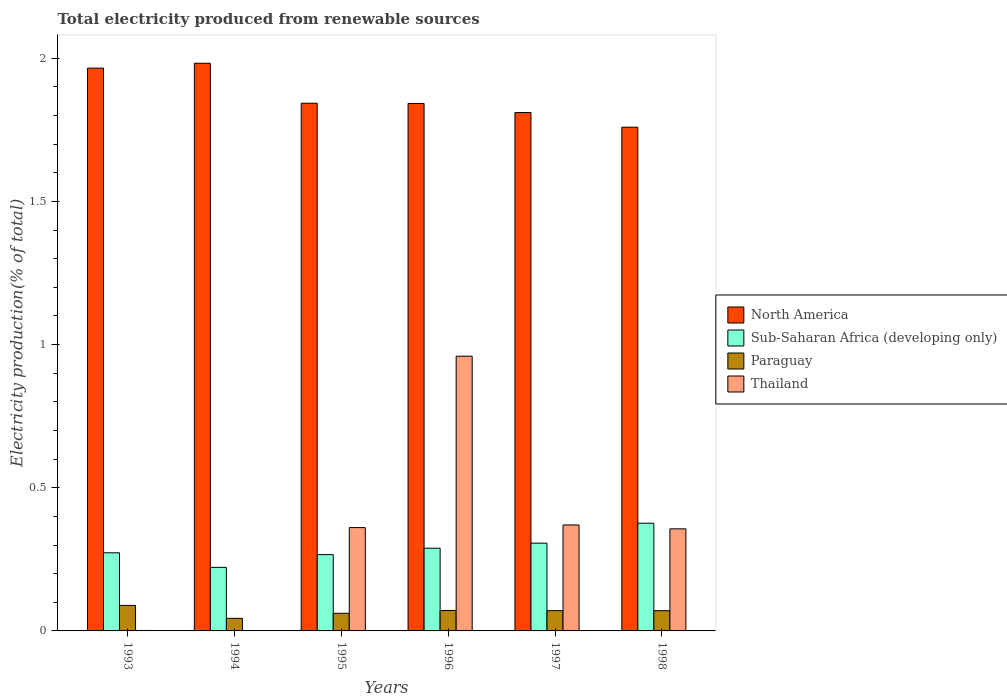How many different coloured bars are there?
Offer a terse response. 4. How many groups of bars are there?
Offer a terse response. 6. Are the number of bars on each tick of the X-axis equal?
Your answer should be very brief. Yes. How many bars are there on the 4th tick from the right?
Ensure brevity in your answer.  4. What is the label of the 1st group of bars from the left?
Ensure brevity in your answer.  1993. What is the total electricity produced in Paraguay in 1995?
Offer a terse response. 0.06. Across all years, what is the maximum total electricity produced in Thailand?
Give a very brief answer. 0.96. Across all years, what is the minimum total electricity produced in North America?
Provide a short and direct response. 1.76. In which year was the total electricity produced in North America maximum?
Offer a very short reply. 1994. In which year was the total electricity produced in Thailand minimum?
Give a very brief answer. 1994. What is the total total electricity produced in Paraguay in the graph?
Ensure brevity in your answer.  0.41. What is the difference between the total electricity produced in North America in 1993 and that in 1996?
Give a very brief answer. 0.12. What is the difference between the total electricity produced in North America in 1993 and the total electricity produced in Thailand in 1995?
Offer a very short reply. 1.6. What is the average total electricity produced in North America per year?
Your answer should be very brief. 1.87. In the year 1997, what is the difference between the total electricity produced in North America and total electricity produced in Paraguay?
Your answer should be compact. 1.74. In how many years, is the total electricity produced in Thailand greater than 0.9 %?
Offer a very short reply. 1. What is the ratio of the total electricity produced in Thailand in 1994 to that in 1997?
Ensure brevity in your answer.  0. Is the total electricity produced in Paraguay in 1994 less than that in 1997?
Make the answer very short. Yes. What is the difference between the highest and the second highest total electricity produced in North America?
Ensure brevity in your answer.  0.02. What is the difference between the highest and the lowest total electricity produced in Paraguay?
Offer a very short reply. 0.05. In how many years, is the total electricity produced in North America greater than the average total electricity produced in North America taken over all years?
Offer a very short reply. 2. Is it the case that in every year, the sum of the total electricity produced in Paraguay and total electricity produced in North America is greater than the sum of total electricity produced in Sub-Saharan Africa (developing only) and total electricity produced in Thailand?
Make the answer very short. Yes. What does the 1st bar from the left in 1993 represents?
Give a very brief answer. North America. What does the 3rd bar from the right in 1993 represents?
Offer a very short reply. Sub-Saharan Africa (developing only). How many bars are there?
Make the answer very short. 24. Where does the legend appear in the graph?
Ensure brevity in your answer.  Center right. How are the legend labels stacked?
Keep it short and to the point. Vertical. What is the title of the graph?
Make the answer very short. Total electricity produced from renewable sources. What is the label or title of the X-axis?
Ensure brevity in your answer.  Years. What is the label or title of the Y-axis?
Keep it short and to the point. Electricity production(% of total). What is the Electricity production(% of total) of North America in 1993?
Give a very brief answer. 1.97. What is the Electricity production(% of total) in Sub-Saharan Africa (developing only) in 1993?
Your response must be concise. 0.27. What is the Electricity production(% of total) of Paraguay in 1993?
Provide a short and direct response. 0.09. What is the Electricity production(% of total) in Thailand in 1993?
Your response must be concise. 0. What is the Electricity production(% of total) in North America in 1994?
Your answer should be compact. 1.98. What is the Electricity production(% of total) in Sub-Saharan Africa (developing only) in 1994?
Ensure brevity in your answer.  0.22. What is the Electricity production(% of total) of Paraguay in 1994?
Your answer should be very brief. 0.04. What is the Electricity production(% of total) of Thailand in 1994?
Give a very brief answer. 0. What is the Electricity production(% of total) in North America in 1995?
Ensure brevity in your answer.  1.84. What is the Electricity production(% of total) of Sub-Saharan Africa (developing only) in 1995?
Your response must be concise. 0.27. What is the Electricity production(% of total) in Paraguay in 1995?
Give a very brief answer. 0.06. What is the Electricity production(% of total) in Thailand in 1995?
Your answer should be compact. 0.36. What is the Electricity production(% of total) in North America in 1996?
Provide a short and direct response. 1.84. What is the Electricity production(% of total) of Sub-Saharan Africa (developing only) in 1996?
Keep it short and to the point. 0.29. What is the Electricity production(% of total) of Paraguay in 1996?
Your response must be concise. 0.07. What is the Electricity production(% of total) of Thailand in 1996?
Offer a very short reply. 0.96. What is the Electricity production(% of total) in North America in 1997?
Your answer should be compact. 1.81. What is the Electricity production(% of total) in Sub-Saharan Africa (developing only) in 1997?
Offer a terse response. 0.31. What is the Electricity production(% of total) in Paraguay in 1997?
Give a very brief answer. 0.07. What is the Electricity production(% of total) in Thailand in 1997?
Provide a short and direct response. 0.37. What is the Electricity production(% of total) in North America in 1998?
Your response must be concise. 1.76. What is the Electricity production(% of total) in Sub-Saharan Africa (developing only) in 1998?
Provide a short and direct response. 0.38. What is the Electricity production(% of total) in Paraguay in 1998?
Offer a terse response. 0.07. What is the Electricity production(% of total) of Thailand in 1998?
Offer a terse response. 0.36. Across all years, what is the maximum Electricity production(% of total) of North America?
Your answer should be very brief. 1.98. Across all years, what is the maximum Electricity production(% of total) in Sub-Saharan Africa (developing only)?
Give a very brief answer. 0.38. Across all years, what is the maximum Electricity production(% of total) in Paraguay?
Give a very brief answer. 0.09. Across all years, what is the maximum Electricity production(% of total) of Thailand?
Ensure brevity in your answer.  0.96. Across all years, what is the minimum Electricity production(% of total) of North America?
Offer a terse response. 1.76. Across all years, what is the minimum Electricity production(% of total) of Sub-Saharan Africa (developing only)?
Your answer should be very brief. 0.22. Across all years, what is the minimum Electricity production(% of total) in Paraguay?
Make the answer very short. 0.04. Across all years, what is the minimum Electricity production(% of total) of Thailand?
Your answer should be compact. 0. What is the total Electricity production(% of total) of North America in the graph?
Keep it short and to the point. 11.2. What is the total Electricity production(% of total) of Sub-Saharan Africa (developing only) in the graph?
Provide a succinct answer. 1.73. What is the total Electricity production(% of total) in Paraguay in the graph?
Ensure brevity in your answer.  0.41. What is the total Electricity production(% of total) of Thailand in the graph?
Ensure brevity in your answer.  2.05. What is the difference between the Electricity production(% of total) of North America in 1993 and that in 1994?
Your answer should be very brief. -0.02. What is the difference between the Electricity production(% of total) of Sub-Saharan Africa (developing only) in 1993 and that in 1994?
Give a very brief answer. 0.05. What is the difference between the Electricity production(% of total) in Paraguay in 1993 and that in 1994?
Provide a short and direct response. 0.05. What is the difference between the Electricity production(% of total) in North America in 1993 and that in 1995?
Give a very brief answer. 0.12. What is the difference between the Electricity production(% of total) in Sub-Saharan Africa (developing only) in 1993 and that in 1995?
Your answer should be compact. 0.01. What is the difference between the Electricity production(% of total) of Paraguay in 1993 and that in 1995?
Your response must be concise. 0.03. What is the difference between the Electricity production(% of total) in Thailand in 1993 and that in 1995?
Your answer should be compact. -0.36. What is the difference between the Electricity production(% of total) in North America in 1993 and that in 1996?
Offer a very short reply. 0.12. What is the difference between the Electricity production(% of total) in Sub-Saharan Africa (developing only) in 1993 and that in 1996?
Offer a very short reply. -0.02. What is the difference between the Electricity production(% of total) of Paraguay in 1993 and that in 1996?
Your answer should be very brief. 0.02. What is the difference between the Electricity production(% of total) in Thailand in 1993 and that in 1996?
Provide a succinct answer. -0.96. What is the difference between the Electricity production(% of total) of North America in 1993 and that in 1997?
Provide a succinct answer. 0.16. What is the difference between the Electricity production(% of total) in Sub-Saharan Africa (developing only) in 1993 and that in 1997?
Offer a very short reply. -0.03. What is the difference between the Electricity production(% of total) in Paraguay in 1993 and that in 1997?
Your answer should be very brief. 0.02. What is the difference between the Electricity production(% of total) of Thailand in 1993 and that in 1997?
Make the answer very short. -0.37. What is the difference between the Electricity production(% of total) in North America in 1993 and that in 1998?
Ensure brevity in your answer.  0.21. What is the difference between the Electricity production(% of total) in Sub-Saharan Africa (developing only) in 1993 and that in 1998?
Provide a succinct answer. -0.1. What is the difference between the Electricity production(% of total) in Paraguay in 1993 and that in 1998?
Keep it short and to the point. 0.02. What is the difference between the Electricity production(% of total) in Thailand in 1993 and that in 1998?
Make the answer very short. -0.35. What is the difference between the Electricity production(% of total) of North America in 1994 and that in 1995?
Offer a terse response. 0.14. What is the difference between the Electricity production(% of total) in Sub-Saharan Africa (developing only) in 1994 and that in 1995?
Your answer should be very brief. -0.04. What is the difference between the Electricity production(% of total) in Paraguay in 1994 and that in 1995?
Your response must be concise. -0.02. What is the difference between the Electricity production(% of total) in Thailand in 1994 and that in 1995?
Your answer should be compact. -0.36. What is the difference between the Electricity production(% of total) of North America in 1994 and that in 1996?
Provide a succinct answer. 0.14. What is the difference between the Electricity production(% of total) of Sub-Saharan Africa (developing only) in 1994 and that in 1996?
Provide a short and direct response. -0.07. What is the difference between the Electricity production(% of total) of Paraguay in 1994 and that in 1996?
Ensure brevity in your answer.  -0.03. What is the difference between the Electricity production(% of total) of Thailand in 1994 and that in 1996?
Offer a very short reply. -0.96. What is the difference between the Electricity production(% of total) of North America in 1994 and that in 1997?
Provide a short and direct response. 0.17. What is the difference between the Electricity production(% of total) in Sub-Saharan Africa (developing only) in 1994 and that in 1997?
Keep it short and to the point. -0.08. What is the difference between the Electricity production(% of total) of Paraguay in 1994 and that in 1997?
Offer a terse response. -0.03. What is the difference between the Electricity production(% of total) of Thailand in 1994 and that in 1997?
Your response must be concise. -0.37. What is the difference between the Electricity production(% of total) of North America in 1994 and that in 1998?
Give a very brief answer. 0.22. What is the difference between the Electricity production(% of total) of Sub-Saharan Africa (developing only) in 1994 and that in 1998?
Your answer should be compact. -0.15. What is the difference between the Electricity production(% of total) in Paraguay in 1994 and that in 1998?
Offer a terse response. -0.03. What is the difference between the Electricity production(% of total) of Thailand in 1994 and that in 1998?
Give a very brief answer. -0.36. What is the difference between the Electricity production(% of total) of North America in 1995 and that in 1996?
Give a very brief answer. 0. What is the difference between the Electricity production(% of total) in Sub-Saharan Africa (developing only) in 1995 and that in 1996?
Provide a succinct answer. -0.02. What is the difference between the Electricity production(% of total) in Paraguay in 1995 and that in 1996?
Offer a terse response. -0.01. What is the difference between the Electricity production(% of total) in Thailand in 1995 and that in 1996?
Ensure brevity in your answer.  -0.6. What is the difference between the Electricity production(% of total) in North America in 1995 and that in 1997?
Make the answer very short. 0.03. What is the difference between the Electricity production(% of total) of Sub-Saharan Africa (developing only) in 1995 and that in 1997?
Offer a terse response. -0.04. What is the difference between the Electricity production(% of total) of Paraguay in 1995 and that in 1997?
Keep it short and to the point. -0.01. What is the difference between the Electricity production(% of total) in Thailand in 1995 and that in 1997?
Your response must be concise. -0.01. What is the difference between the Electricity production(% of total) of North America in 1995 and that in 1998?
Give a very brief answer. 0.08. What is the difference between the Electricity production(% of total) in Sub-Saharan Africa (developing only) in 1995 and that in 1998?
Make the answer very short. -0.11. What is the difference between the Electricity production(% of total) in Paraguay in 1995 and that in 1998?
Your response must be concise. -0.01. What is the difference between the Electricity production(% of total) in Thailand in 1995 and that in 1998?
Provide a short and direct response. 0. What is the difference between the Electricity production(% of total) of North America in 1996 and that in 1997?
Keep it short and to the point. 0.03. What is the difference between the Electricity production(% of total) of Sub-Saharan Africa (developing only) in 1996 and that in 1997?
Provide a short and direct response. -0.02. What is the difference between the Electricity production(% of total) in Paraguay in 1996 and that in 1997?
Make the answer very short. 0. What is the difference between the Electricity production(% of total) of Thailand in 1996 and that in 1997?
Give a very brief answer. 0.59. What is the difference between the Electricity production(% of total) of North America in 1996 and that in 1998?
Provide a short and direct response. 0.08. What is the difference between the Electricity production(% of total) in Sub-Saharan Africa (developing only) in 1996 and that in 1998?
Give a very brief answer. -0.09. What is the difference between the Electricity production(% of total) of Paraguay in 1996 and that in 1998?
Provide a succinct answer. 0. What is the difference between the Electricity production(% of total) of Thailand in 1996 and that in 1998?
Your response must be concise. 0.6. What is the difference between the Electricity production(% of total) in North America in 1997 and that in 1998?
Provide a short and direct response. 0.05. What is the difference between the Electricity production(% of total) in Sub-Saharan Africa (developing only) in 1997 and that in 1998?
Offer a terse response. -0.07. What is the difference between the Electricity production(% of total) of Paraguay in 1997 and that in 1998?
Give a very brief answer. 0. What is the difference between the Electricity production(% of total) in Thailand in 1997 and that in 1998?
Make the answer very short. 0.01. What is the difference between the Electricity production(% of total) of North America in 1993 and the Electricity production(% of total) of Sub-Saharan Africa (developing only) in 1994?
Your answer should be compact. 1.74. What is the difference between the Electricity production(% of total) in North America in 1993 and the Electricity production(% of total) in Paraguay in 1994?
Your response must be concise. 1.92. What is the difference between the Electricity production(% of total) in North America in 1993 and the Electricity production(% of total) in Thailand in 1994?
Keep it short and to the point. 1.96. What is the difference between the Electricity production(% of total) in Sub-Saharan Africa (developing only) in 1993 and the Electricity production(% of total) in Paraguay in 1994?
Offer a very short reply. 0.23. What is the difference between the Electricity production(% of total) in Sub-Saharan Africa (developing only) in 1993 and the Electricity production(% of total) in Thailand in 1994?
Your response must be concise. 0.27. What is the difference between the Electricity production(% of total) in Paraguay in 1993 and the Electricity production(% of total) in Thailand in 1994?
Provide a succinct answer. 0.09. What is the difference between the Electricity production(% of total) in North America in 1993 and the Electricity production(% of total) in Sub-Saharan Africa (developing only) in 1995?
Keep it short and to the point. 1.7. What is the difference between the Electricity production(% of total) in North America in 1993 and the Electricity production(% of total) in Paraguay in 1995?
Provide a succinct answer. 1.9. What is the difference between the Electricity production(% of total) in North America in 1993 and the Electricity production(% of total) in Thailand in 1995?
Provide a short and direct response. 1.6. What is the difference between the Electricity production(% of total) of Sub-Saharan Africa (developing only) in 1993 and the Electricity production(% of total) of Paraguay in 1995?
Keep it short and to the point. 0.21. What is the difference between the Electricity production(% of total) in Sub-Saharan Africa (developing only) in 1993 and the Electricity production(% of total) in Thailand in 1995?
Make the answer very short. -0.09. What is the difference between the Electricity production(% of total) in Paraguay in 1993 and the Electricity production(% of total) in Thailand in 1995?
Ensure brevity in your answer.  -0.27. What is the difference between the Electricity production(% of total) in North America in 1993 and the Electricity production(% of total) in Sub-Saharan Africa (developing only) in 1996?
Ensure brevity in your answer.  1.68. What is the difference between the Electricity production(% of total) of North America in 1993 and the Electricity production(% of total) of Paraguay in 1996?
Ensure brevity in your answer.  1.89. What is the difference between the Electricity production(% of total) in Sub-Saharan Africa (developing only) in 1993 and the Electricity production(% of total) in Paraguay in 1996?
Your answer should be compact. 0.2. What is the difference between the Electricity production(% of total) of Sub-Saharan Africa (developing only) in 1993 and the Electricity production(% of total) of Thailand in 1996?
Provide a succinct answer. -0.69. What is the difference between the Electricity production(% of total) of Paraguay in 1993 and the Electricity production(% of total) of Thailand in 1996?
Offer a very short reply. -0.87. What is the difference between the Electricity production(% of total) in North America in 1993 and the Electricity production(% of total) in Sub-Saharan Africa (developing only) in 1997?
Make the answer very short. 1.66. What is the difference between the Electricity production(% of total) of North America in 1993 and the Electricity production(% of total) of Paraguay in 1997?
Provide a succinct answer. 1.89. What is the difference between the Electricity production(% of total) in North America in 1993 and the Electricity production(% of total) in Thailand in 1997?
Offer a terse response. 1.6. What is the difference between the Electricity production(% of total) of Sub-Saharan Africa (developing only) in 1993 and the Electricity production(% of total) of Paraguay in 1997?
Provide a succinct answer. 0.2. What is the difference between the Electricity production(% of total) in Sub-Saharan Africa (developing only) in 1993 and the Electricity production(% of total) in Thailand in 1997?
Provide a short and direct response. -0.1. What is the difference between the Electricity production(% of total) of Paraguay in 1993 and the Electricity production(% of total) of Thailand in 1997?
Your answer should be compact. -0.28. What is the difference between the Electricity production(% of total) in North America in 1993 and the Electricity production(% of total) in Sub-Saharan Africa (developing only) in 1998?
Make the answer very short. 1.59. What is the difference between the Electricity production(% of total) in North America in 1993 and the Electricity production(% of total) in Paraguay in 1998?
Your response must be concise. 1.89. What is the difference between the Electricity production(% of total) in North America in 1993 and the Electricity production(% of total) in Thailand in 1998?
Keep it short and to the point. 1.61. What is the difference between the Electricity production(% of total) of Sub-Saharan Africa (developing only) in 1993 and the Electricity production(% of total) of Paraguay in 1998?
Your answer should be compact. 0.2. What is the difference between the Electricity production(% of total) of Sub-Saharan Africa (developing only) in 1993 and the Electricity production(% of total) of Thailand in 1998?
Give a very brief answer. -0.08. What is the difference between the Electricity production(% of total) in Paraguay in 1993 and the Electricity production(% of total) in Thailand in 1998?
Make the answer very short. -0.27. What is the difference between the Electricity production(% of total) in North America in 1994 and the Electricity production(% of total) in Sub-Saharan Africa (developing only) in 1995?
Give a very brief answer. 1.72. What is the difference between the Electricity production(% of total) in North America in 1994 and the Electricity production(% of total) in Paraguay in 1995?
Ensure brevity in your answer.  1.92. What is the difference between the Electricity production(% of total) of North America in 1994 and the Electricity production(% of total) of Thailand in 1995?
Your response must be concise. 1.62. What is the difference between the Electricity production(% of total) of Sub-Saharan Africa (developing only) in 1994 and the Electricity production(% of total) of Paraguay in 1995?
Provide a short and direct response. 0.16. What is the difference between the Electricity production(% of total) in Sub-Saharan Africa (developing only) in 1994 and the Electricity production(% of total) in Thailand in 1995?
Make the answer very short. -0.14. What is the difference between the Electricity production(% of total) in Paraguay in 1994 and the Electricity production(% of total) in Thailand in 1995?
Ensure brevity in your answer.  -0.32. What is the difference between the Electricity production(% of total) in North America in 1994 and the Electricity production(% of total) in Sub-Saharan Africa (developing only) in 1996?
Keep it short and to the point. 1.69. What is the difference between the Electricity production(% of total) in North America in 1994 and the Electricity production(% of total) in Paraguay in 1996?
Provide a short and direct response. 1.91. What is the difference between the Electricity production(% of total) of North America in 1994 and the Electricity production(% of total) of Thailand in 1996?
Provide a short and direct response. 1.02. What is the difference between the Electricity production(% of total) in Sub-Saharan Africa (developing only) in 1994 and the Electricity production(% of total) in Paraguay in 1996?
Your answer should be very brief. 0.15. What is the difference between the Electricity production(% of total) in Sub-Saharan Africa (developing only) in 1994 and the Electricity production(% of total) in Thailand in 1996?
Your response must be concise. -0.74. What is the difference between the Electricity production(% of total) of Paraguay in 1994 and the Electricity production(% of total) of Thailand in 1996?
Your response must be concise. -0.92. What is the difference between the Electricity production(% of total) of North America in 1994 and the Electricity production(% of total) of Sub-Saharan Africa (developing only) in 1997?
Your response must be concise. 1.68. What is the difference between the Electricity production(% of total) in North America in 1994 and the Electricity production(% of total) in Paraguay in 1997?
Ensure brevity in your answer.  1.91. What is the difference between the Electricity production(% of total) in North America in 1994 and the Electricity production(% of total) in Thailand in 1997?
Ensure brevity in your answer.  1.61. What is the difference between the Electricity production(% of total) of Sub-Saharan Africa (developing only) in 1994 and the Electricity production(% of total) of Paraguay in 1997?
Make the answer very short. 0.15. What is the difference between the Electricity production(% of total) in Sub-Saharan Africa (developing only) in 1994 and the Electricity production(% of total) in Thailand in 1997?
Give a very brief answer. -0.15. What is the difference between the Electricity production(% of total) of Paraguay in 1994 and the Electricity production(% of total) of Thailand in 1997?
Your answer should be compact. -0.33. What is the difference between the Electricity production(% of total) in North America in 1994 and the Electricity production(% of total) in Sub-Saharan Africa (developing only) in 1998?
Offer a very short reply. 1.61. What is the difference between the Electricity production(% of total) of North America in 1994 and the Electricity production(% of total) of Paraguay in 1998?
Offer a terse response. 1.91. What is the difference between the Electricity production(% of total) in North America in 1994 and the Electricity production(% of total) in Thailand in 1998?
Your answer should be very brief. 1.63. What is the difference between the Electricity production(% of total) in Sub-Saharan Africa (developing only) in 1994 and the Electricity production(% of total) in Paraguay in 1998?
Offer a terse response. 0.15. What is the difference between the Electricity production(% of total) of Sub-Saharan Africa (developing only) in 1994 and the Electricity production(% of total) of Thailand in 1998?
Offer a terse response. -0.13. What is the difference between the Electricity production(% of total) of Paraguay in 1994 and the Electricity production(% of total) of Thailand in 1998?
Offer a terse response. -0.31. What is the difference between the Electricity production(% of total) of North America in 1995 and the Electricity production(% of total) of Sub-Saharan Africa (developing only) in 1996?
Offer a terse response. 1.55. What is the difference between the Electricity production(% of total) in North America in 1995 and the Electricity production(% of total) in Paraguay in 1996?
Provide a short and direct response. 1.77. What is the difference between the Electricity production(% of total) of North America in 1995 and the Electricity production(% of total) of Thailand in 1996?
Your answer should be very brief. 0.88. What is the difference between the Electricity production(% of total) of Sub-Saharan Africa (developing only) in 1995 and the Electricity production(% of total) of Paraguay in 1996?
Provide a short and direct response. 0.2. What is the difference between the Electricity production(% of total) of Sub-Saharan Africa (developing only) in 1995 and the Electricity production(% of total) of Thailand in 1996?
Make the answer very short. -0.69. What is the difference between the Electricity production(% of total) in Paraguay in 1995 and the Electricity production(% of total) in Thailand in 1996?
Offer a very short reply. -0.9. What is the difference between the Electricity production(% of total) in North America in 1995 and the Electricity production(% of total) in Sub-Saharan Africa (developing only) in 1997?
Provide a short and direct response. 1.54. What is the difference between the Electricity production(% of total) in North America in 1995 and the Electricity production(% of total) in Paraguay in 1997?
Your answer should be very brief. 1.77. What is the difference between the Electricity production(% of total) in North America in 1995 and the Electricity production(% of total) in Thailand in 1997?
Your answer should be very brief. 1.47. What is the difference between the Electricity production(% of total) in Sub-Saharan Africa (developing only) in 1995 and the Electricity production(% of total) in Paraguay in 1997?
Offer a terse response. 0.2. What is the difference between the Electricity production(% of total) of Sub-Saharan Africa (developing only) in 1995 and the Electricity production(% of total) of Thailand in 1997?
Provide a short and direct response. -0.1. What is the difference between the Electricity production(% of total) of Paraguay in 1995 and the Electricity production(% of total) of Thailand in 1997?
Ensure brevity in your answer.  -0.31. What is the difference between the Electricity production(% of total) in North America in 1995 and the Electricity production(% of total) in Sub-Saharan Africa (developing only) in 1998?
Give a very brief answer. 1.47. What is the difference between the Electricity production(% of total) of North America in 1995 and the Electricity production(% of total) of Paraguay in 1998?
Offer a very short reply. 1.77. What is the difference between the Electricity production(% of total) of North America in 1995 and the Electricity production(% of total) of Thailand in 1998?
Ensure brevity in your answer.  1.49. What is the difference between the Electricity production(% of total) in Sub-Saharan Africa (developing only) in 1995 and the Electricity production(% of total) in Paraguay in 1998?
Provide a succinct answer. 0.2. What is the difference between the Electricity production(% of total) in Sub-Saharan Africa (developing only) in 1995 and the Electricity production(% of total) in Thailand in 1998?
Provide a succinct answer. -0.09. What is the difference between the Electricity production(% of total) in Paraguay in 1995 and the Electricity production(% of total) in Thailand in 1998?
Keep it short and to the point. -0.29. What is the difference between the Electricity production(% of total) of North America in 1996 and the Electricity production(% of total) of Sub-Saharan Africa (developing only) in 1997?
Your answer should be very brief. 1.54. What is the difference between the Electricity production(% of total) in North America in 1996 and the Electricity production(% of total) in Paraguay in 1997?
Ensure brevity in your answer.  1.77. What is the difference between the Electricity production(% of total) in North America in 1996 and the Electricity production(% of total) in Thailand in 1997?
Your response must be concise. 1.47. What is the difference between the Electricity production(% of total) of Sub-Saharan Africa (developing only) in 1996 and the Electricity production(% of total) of Paraguay in 1997?
Offer a terse response. 0.22. What is the difference between the Electricity production(% of total) of Sub-Saharan Africa (developing only) in 1996 and the Electricity production(% of total) of Thailand in 1997?
Give a very brief answer. -0.08. What is the difference between the Electricity production(% of total) in Paraguay in 1996 and the Electricity production(% of total) in Thailand in 1997?
Make the answer very short. -0.3. What is the difference between the Electricity production(% of total) of North America in 1996 and the Electricity production(% of total) of Sub-Saharan Africa (developing only) in 1998?
Your answer should be very brief. 1.47. What is the difference between the Electricity production(% of total) of North America in 1996 and the Electricity production(% of total) of Paraguay in 1998?
Your response must be concise. 1.77. What is the difference between the Electricity production(% of total) of North America in 1996 and the Electricity production(% of total) of Thailand in 1998?
Your answer should be very brief. 1.49. What is the difference between the Electricity production(% of total) in Sub-Saharan Africa (developing only) in 1996 and the Electricity production(% of total) in Paraguay in 1998?
Provide a succinct answer. 0.22. What is the difference between the Electricity production(% of total) in Sub-Saharan Africa (developing only) in 1996 and the Electricity production(% of total) in Thailand in 1998?
Make the answer very short. -0.07. What is the difference between the Electricity production(% of total) of Paraguay in 1996 and the Electricity production(% of total) of Thailand in 1998?
Your answer should be compact. -0.29. What is the difference between the Electricity production(% of total) in North America in 1997 and the Electricity production(% of total) in Sub-Saharan Africa (developing only) in 1998?
Keep it short and to the point. 1.43. What is the difference between the Electricity production(% of total) of North America in 1997 and the Electricity production(% of total) of Paraguay in 1998?
Provide a succinct answer. 1.74. What is the difference between the Electricity production(% of total) of North America in 1997 and the Electricity production(% of total) of Thailand in 1998?
Offer a very short reply. 1.45. What is the difference between the Electricity production(% of total) in Sub-Saharan Africa (developing only) in 1997 and the Electricity production(% of total) in Paraguay in 1998?
Give a very brief answer. 0.24. What is the difference between the Electricity production(% of total) in Sub-Saharan Africa (developing only) in 1997 and the Electricity production(% of total) in Thailand in 1998?
Make the answer very short. -0.05. What is the difference between the Electricity production(% of total) of Paraguay in 1997 and the Electricity production(% of total) of Thailand in 1998?
Offer a very short reply. -0.29. What is the average Electricity production(% of total) of North America per year?
Provide a succinct answer. 1.87. What is the average Electricity production(% of total) of Sub-Saharan Africa (developing only) per year?
Your response must be concise. 0.29. What is the average Electricity production(% of total) in Paraguay per year?
Offer a terse response. 0.07. What is the average Electricity production(% of total) in Thailand per year?
Your answer should be compact. 0.34. In the year 1993, what is the difference between the Electricity production(% of total) in North America and Electricity production(% of total) in Sub-Saharan Africa (developing only)?
Give a very brief answer. 1.69. In the year 1993, what is the difference between the Electricity production(% of total) of North America and Electricity production(% of total) of Paraguay?
Offer a very short reply. 1.88. In the year 1993, what is the difference between the Electricity production(% of total) in North America and Electricity production(% of total) in Thailand?
Offer a terse response. 1.96. In the year 1993, what is the difference between the Electricity production(% of total) in Sub-Saharan Africa (developing only) and Electricity production(% of total) in Paraguay?
Your response must be concise. 0.18. In the year 1993, what is the difference between the Electricity production(% of total) in Sub-Saharan Africa (developing only) and Electricity production(% of total) in Thailand?
Give a very brief answer. 0.27. In the year 1993, what is the difference between the Electricity production(% of total) of Paraguay and Electricity production(% of total) of Thailand?
Your answer should be very brief. 0.09. In the year 1994, what is the difference between the Electricity production(% of total) of North America and Electricity production(% of total) of Sub-Saharan Africa (developing only)?
Provide a succinct answer. 1.76. In the year 1994, what is the difference between the Electricity production(% of total) of North America and Electricity production(% of total) of Paraguay?
Ensure brevity in your answer.  1.94. In the year 1994, what is the difference between the Electricity production(% of total) of North America and Electricity production(% of total) of Thailand?
Provide a succinct answer. 1.98. In the year 1994, what is the difference between the Electricity production(% of total) of Sub-Saharan Africa (developing only) and Electricity production(% of total) of Paraguay?
Offer a terse response. 0.18. In the year 1994, what is the difference between the Electricity production(% of total) in Sub-Saharan Africa (developing only) and Electricity production(% of total) in Thailand?
Provide a succinct answer. 0.22. In the year 1994, what is the difference between the Electricity production(% of total) in Paraguay and Electricity production(% of total) in Thailand?
Ensure brevity in your answer.  0.04. In the year 1995, what is the difference between the Electricity production(% of total) in North America and Electricity production(% of total) in Sub-Saharan Africa (developing only)?
Offer a very short reply. 1.58. In the year 1995, what is the difference between the Electricity production(% of total) of North America and Electricity production(% of total) of Paraguay?
Your answer should be very brief. 1.78. In the year 1995, what is the difference between the Electricity production(% of total) in North America and Electricity production(% of total) in Thailand?
Offer a terse response. 1.48. In the year 1995, what is the difference between the Electricity production(% of total) of Sub-Saharan Africa (developing only) and Electricity production(% of total) of Paraguay?
Give a very brief answer. 0.2. In the year 1995, what is the difference between the Electricity production(% of total) of Sub-Saharan Africa (developing only) and Electricity production(% of total) of Thailand?
Provide a short and direct response. -0.09. In the year 1995, what is the difference between the Electricity production(% of total) of Paraguay and Electricity production(% of total) of Thailand?
Provide a succinct answer. -0.3. In the year 1996, what is the difference between the Electricity production(% of total) of North America and Electricity production(% of total) of Sub-Saharan Africa (developing only)?
Offer a very short reply. 1.55. In the year 1996, what is the difference between the Electricity production(% of total) in North America and Electricity production(% of total) in Paraguay?
Keep it short and to the point. 1.77. In the year 1996, what is the difference between the Electricity production(% of total) in North America and Electricity production(% of total) in Thailand?
Keep it short and to the point. 0.88. In the year 1996, what is the difference between the Electricity production(% of total) in Sub-Saharan Africa (developing only) and Electricity production(% of total) in Paraguay?
Offer a very short reply. 0.22. In the year 1996, what is the difference between the Electricity production(% of total) in Sub-Saharan Africa (developing only) and Electricity production(% of total) in Thailand?
Your response must be concise. -0.67. In the year 1996, what is the difference between the Electricity production(% of total) in Paraguay and Electricity production(% of total) in Thailand?
Keep it short and to the point. -0.89. In the year 1997, what is the difference between the Electricity production(% of total) in North America and Electricity production(% of total) in Sub-Saharan Africa (developing only)?
Make the answer very short. 1.5. In the year 1997, what is the difference between the Electricity production(% of total) in North America and Electricity production(% of total) in Paraguay?
Provide a succinct answer. 1.74. In the year 1997, what is the difference between the Electricity production(% of total) in North America and Electricity production(% of total) in Thailand?
Make the answer very short. 1.44. In the year 1997, what is the difference between the Electricity production(% of total) of Sub-Saharan Africa (developing only) and Electricity production(% of total) of Paraguay?
Provide a succinct answer. 0.24. In the year 1997, what is the difference between the Electricity production(% of total) of Sub-Saharan Africa (developing only) and Electricity production(% of total) of Thailand?
Ensure brevity in your answer.  -0.06. In the year 1997, what is the difference between the Electricity production(% of total) in Paraguay and Electricity production(% of total) in Thailand?
Your answer should be compact. -0.3. In the year 1998, what is the difference between the Electricity production(% of total) of North America and Electricity production(% of total) of Sub-Saharan Africa (developing only)?
Offer a very short reply. 1.38. In the year 1998, what is the difference between the Electricity production(% of total) of North America and Electricity production(% of total) of Paraguay?
Provide a short and direct response. 1.69. In the year 1998, what is the difference between the Electricity production(% of total) in North America and Electricity production(% of total) in Thailand?
Your answer should be very brief. 1.4. In the year 1998, what is the difference between the Electricity production(% of total) in Sub-Saharan Africa (developing only) and Electricity production(% of total) in Paraguay?
Your response must be concise. 0.31. In the year 1998, what is the difference between the Electricity production(% of total) of Sub-Saharan Africa (developing only) and Electricity production(% of total) of Thailand?
Your answer should be compact. 0.02. In the year 1998, what is the difference between the Electricity production(% of total) of Paraguay and Electricity production(% of total) of Thailand?
Offer a very short reply. -0.29. What is the ratio of the Electricity production(% of total) in North America in 1993 to that in 1994?
Provide a succinct answer. 0.99. What is the ratio of the Electricity production(% of total) of Sub-Saharan Africa (developing only) in 1993 to that in 1994?
Your answer should be very brief. 1.23. What is the ratio of the Electricity production(% of total) of Paraguay in 1993 to that in 1994?
Your response must be concise. 2.03. What is the ratio of the Electricity production(% of total) in Thailand in 1993 to that in 1994?
Provide a succinct answer. 1.12. What is the ratio of the Electricity production(% of total) of North America in 1993 to that in 1995?
Provide a succinct answer. 1.07. What is the ratio of the Electricity production(% of total) in Sub-Saharan Africa (developing only) in 1993 to that in 1995?
Your response must be concise. 1.02. What is the ratio of the Electricity production(% of total) in Paraguay in 1993 to that in 1995?
Provide a short and direct response. 1.45. What is the ratio of the Electricity production(% of total) in Thailand in 1993 to that in 1995?
Your response must be concise. 0. What is the ratio of the Electricity production(% of total) of North America in 1993 to that in 1996?
Offer a very short reply. 1.07. What is the ratio of the Electricity production(% of total) of Sub-Saharan Africa (developing only) in 1993 to that in 1996?
Offer a very short reply. 0.94. What is the ratio of the Electricity production(% of total) of Paraguay in 1993 to that in 1996?
Your response must be concise. 1.25. What is the ratio of the Electricity production(% of total) of Thailand in 1993 to that in 1996?
Provide a short and direct response. 0. What is the ratio of the Electricity production(% of total) in North America in 1993 to that in 1997?
Offer a very short reply. 1.09. What is the ratio of the Electricity production(% of total) of Sub-Saharan Africa (developing only) in 1993 to that in 1997?
Make the answer very short. 0.89. What is the ratio of the Electricity production(% of total) of Paraguay in 1993 to that in 1997?
Keep it short and to the point. 1.26. What is the ratio of the Electricity production(% of total) of Thailand in 1993 to that in 1997?
Keep it short and to the point. 0. What is the ratio of the Electricity production(% of total) in North America in 1993 to that in 1998?
Your response must be concise. 1.12. What is the ratio of the Electricity production(% of total) in Sub-Saharan Africa (developing only) in 1993 to that in 1998?
Provide a succinct answer. 0.73. What is the ratio of the Electricity production(% of total) in Paraguay in 1993 to that in 1998?
Offer a terse response. 1.26. What is the ratio of the Electricity production(% of total) of Thailand in 1993 to that in 1998?
Your response must be concise. 0. What is the ratio of the Electricity production(% of total) in North America in 1994 to that in 1995?
Ensure brevity in your answer.  1.08. What is the ratio of the Electricity production(% of total) in Sub-Saharan Africa (developing only) in 1994 to that in 1995?
Make the answer very short. 0.83. What is the ratio of the Electricity production(% of total) in Paraguay in 1994 to that in 1995?
Your response must be concise. 0.71. What is the ratio of the Electricity production(% of total) in Thailand in 1994 to that in 1995?
Ensure brevity in your answer.  0. What is the ratio of the Electricity production(% of total) of North America in 1994 to that in 1996?
Provide a succinct answer. 1.08. What is the ratio of the Electricity production(% of total) of Sub-Saharan Africa (developing only) in 1994 to that in 1996?
Your response must be concise. 0.77. What is the ratio of the Electricity production(% of total) in Paraguay in 1994 to that in 1996?
Make the answer very short. 0.62. What is the ratio of the Electricity production(% of total) of Thailand in 1994 to that in 1996?
Provide a succinct answer. 0. What is the ratio of the Electricity production(% of total) in North America in 1994 to that in 1997?
Give a very brief answer. 1.1. What is the ratio of the Electricity production(% of total) in Sub-Saharan Africa (developing only) in 1994 to that in 1997?
Give a very brief answer. 0.72. What is the ratio of the Electricity production(% of total) in Paraguay in 1994 to that in 1997?
Give a very brief answer. 0.62. What is the ratio of the Electricity production(% of total) of Thailand in 1994 to that in 1997?
Give a very brief answer. 0. What is the ratio of the Electricity production(% of total) in North America in 1994 to that in 1998?
Offer a very short reply. 1.13. What is the ratio of the Electricity production(% of total) in Sub-Saharan Africa (developing only) in 1994 to that in 1998?
Provide a succinct answer. 0.59. What is the ratio of the Electricity production(% of total) in Paraguay in 1994 to that in 1998?
Give a very brief answer. 0.62. What is the ratio of the Electricity production(% of total) in Thailand in 1994 to that in 1998?
Ensure brevity in your answer.  0. What is the ratio of the Electricity production(% of total) of North America in 1995 to that in 1996?
Your response must be concise. 1. What is the ratio of the Electricity production(% of total) of Sub-Saharan Africa (developing only) in 1995 to that in 1996?
Keep it short and to the point. 0.92. What is the ratio of the Electricity production(% of total) in Paraguay in 1995 to that in 1996?
Your answer should be very brief. 0.86. What is the ratio of the Electricity production(% of total) in Thailand in 1995 to that in 1996?
Offer a terse response. 0.38. What is the ratio of the Electricity production(% of total) in North America in 1995 to that in 1997?
Offer a terse response. 1.02. What is the ratio of the Electricity production(% of total) of Sub-Saharan Africa (developing only) in 1995 to that in 1997?
Offer a terse response. 0.87. What is the ratio of the Electricity production(% of total) of Paraguay in 1995 to that in 1997?
Ensure brevity in your answer.  0.87. What is the ratio of the Electricity production(% of total) of Thailand in 1995 to that in 1997?
Ensure brevity in your answer.  0.98. What is the ratio of the Electricity production(% of total) in North America in 1995 to that in 1998?
Your response must be concise. 1.05. What is the ratio of the Electricity production(% of total) in Sub-Saharan Africa (developing only) in 1995 to that in 1998?
Make the answer very short. 0.71. What is the ratio of the Electricity production(% of total) in Paraguay in 1995 to that in 1998?
Provide a short and direct response. 0.87. What is the ratio of the Electricity production(% of total) in Thailand in 1995 to that in 1998?
Your answer should be very brief. 1.01. What is the ratio of the Electricity production(% of total) in North America in 1996 to that in 1997?
Ensure brevity in your answer.  1.02. What is the ratio of the Electricity production(% of total) in Sub-Saharan Africa (developing only) in 1996 to that in 1997?
Offer a terse response. 0.94. What is the ratio of the Electricity production(% of total) of Paraguay in 1996 to that in 1997?
Your response must be concise. 1.01. What is the ratio of the Electricity production(% of total) of Thailand in 1996 to that in 1997?
Keep it short and to the point. 2.59. What is the ratio of the Electricity production(% of total) in North America in 1996 to that in 1998?
Your answer should be compact. 1.05. What is the ratio of the Electricity production(% of total) of Sub-Saharan Africa (developing only) in 1996 to that in 1998?
Offer a very short reply. 0.77. What is the ratio of the Electricity production(% of total) in Paraguay in 1996 to that in 1998?
Offer a very short reply. 1.01. What is the ratio of the Electricity production(% of total) of Thailand in 1996 to that in 1998?
Provide a succinct answer. 2.69. What is the ratio of the Electricity production(% of total) of North America in 1997 to that in 1998?
Your answer should be compact. 1.03. What is the ratio of the Electricity production(% of total) in Sub-Saharan Africa (developing only) in 1997 to that in 1998?
Offer a terse response. 0.81. What is the ratio of the Electricity production(% of total) of Thailand in 1997 to that in 1998?
Your answer should be compact. 1.04. What is the difference between the highest and the second highest Electricity production(% of total) in North America?
Your answer should be compact. 0.02. What is the difference between the highest and the second highest Electricity production(% of total) of Sub-Saharan Africa (developing only)?
Make the answer very short. 0.07. What is the difference between the highest and the second highest Electricity production(% of total) in Paraguay?
Offer a very short reply. 0.02. What is the difference between the highest and the second highest Electricity production(% of total) of Thailand?
Provide a succinct answer. 0.59. What is the difference between the highest and the lowest Electricity production(% of total) of North America?
Offer a very short reply. 0.22. What is the difference between the highest and the lowest Electricity production(% of total) of Sub-Saharan Africa (developing only)?
Your answer should be very brief. 0.15. What is the difference between the highest and the lowest Electricity production(% of total) of Paraguay?
Give a very brief answer. 0.05. What is the difference between the highest and the lowest Electricity production(% of total) of Thailand?
Your answer should be compact. 0.96. 